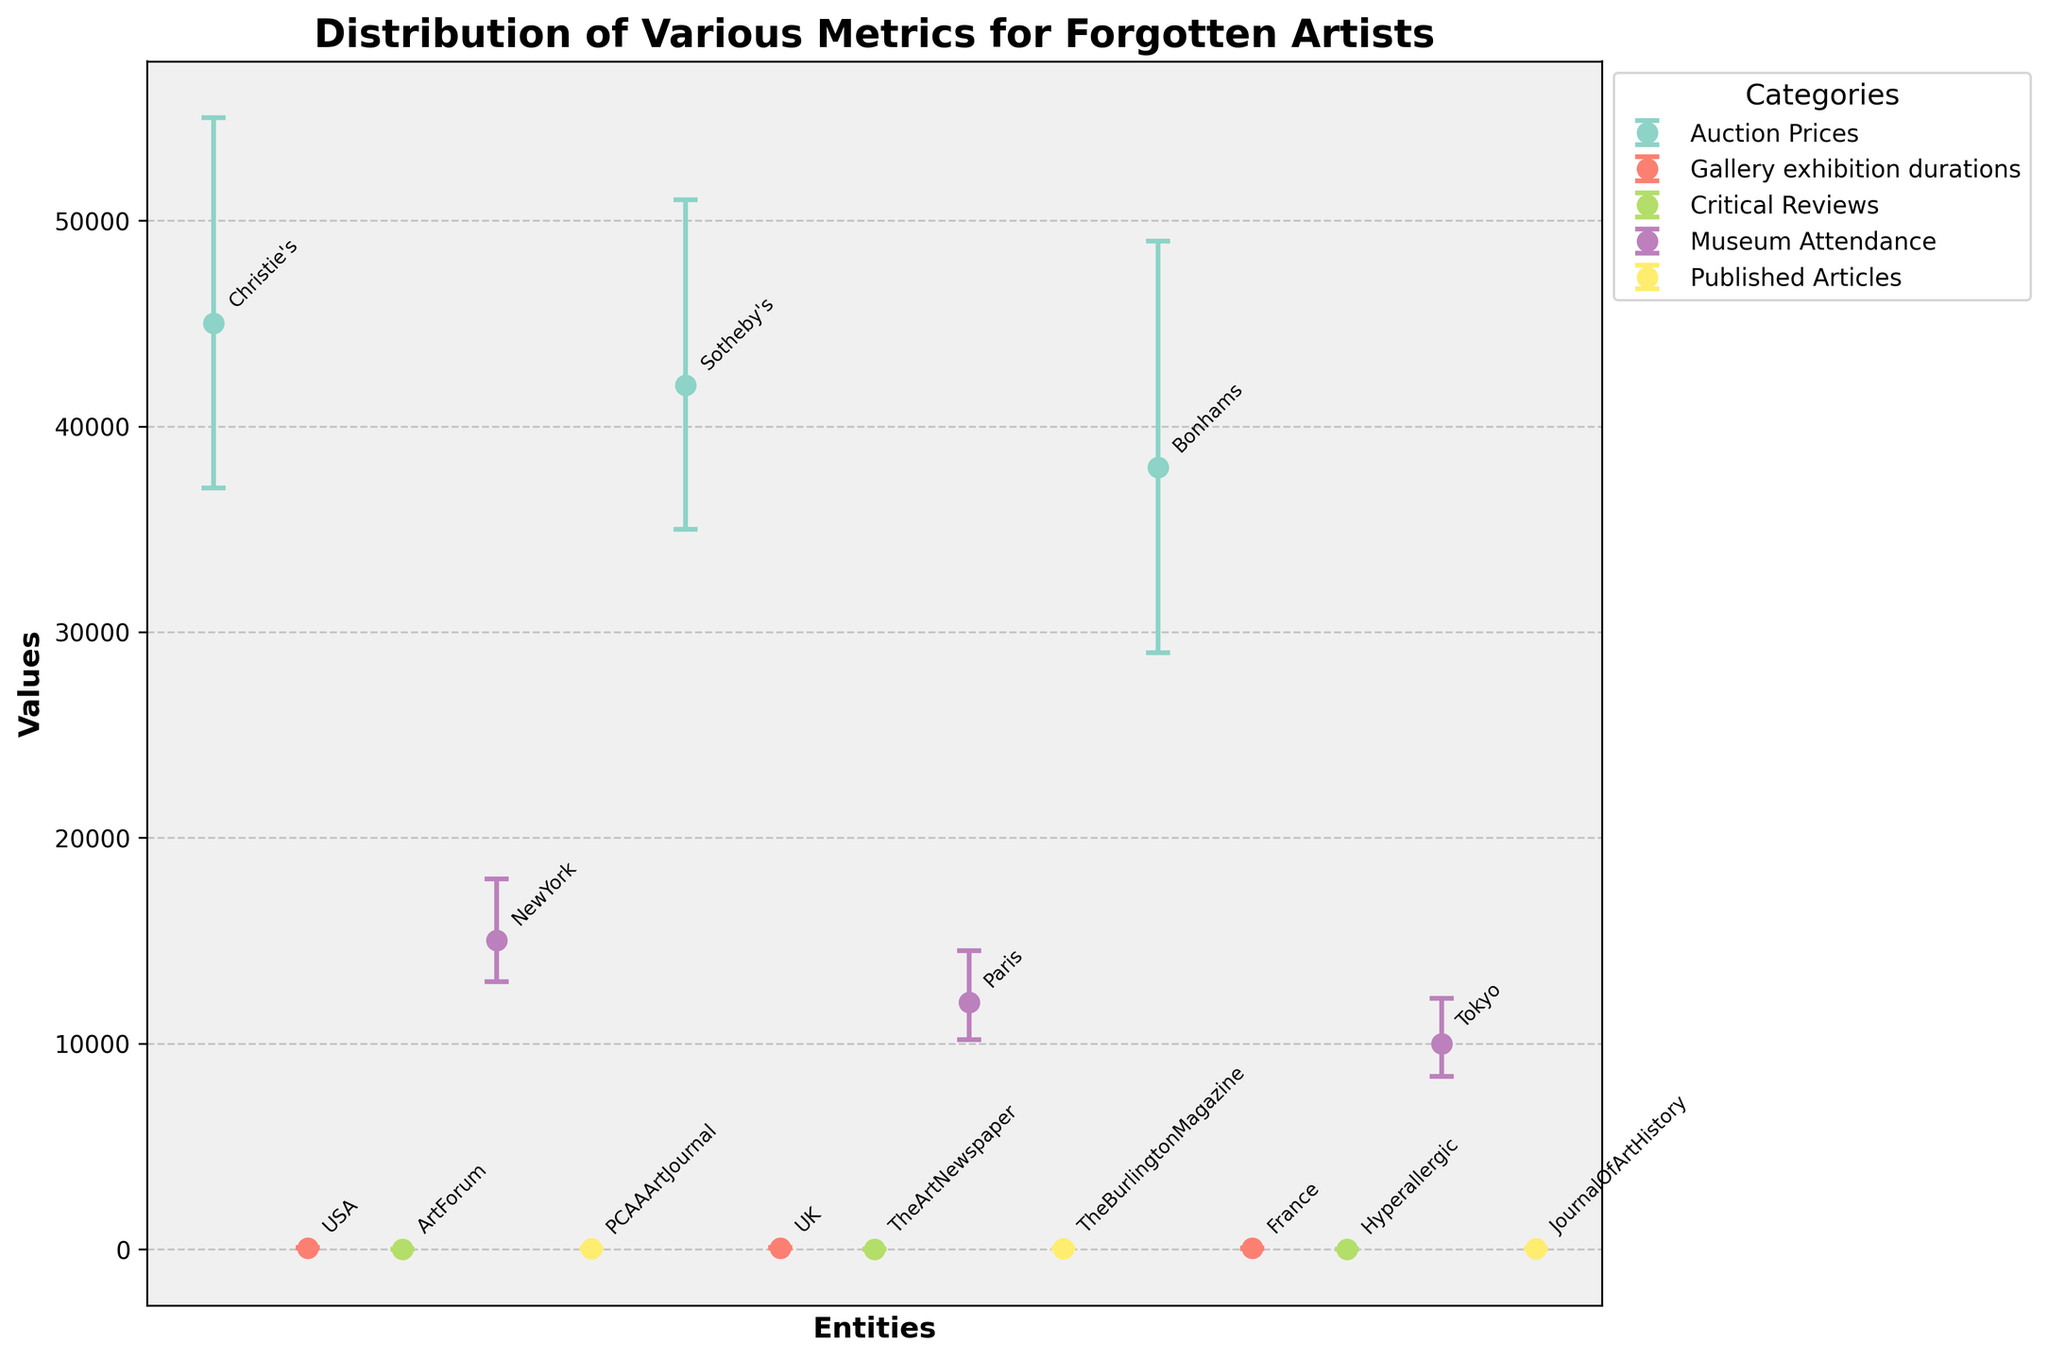What's the highest average auction price among the auction houses? Identify the category "Auction Prices" and compare the average prices. Christie's has an average price of 45,000, Sotheby's has 42,000, and Bonhams has 38,000. Christie's has the highest average auction price.
Answer: Christie's Which gallery exhibition duration has the smallest lower error bar? Look at the "Gallery exhibition durations" category. The lower error bars for USA, UK, and France are 10, 15, and 8, respectively. France has the smallest lower error bar.
Answer: France What’s the range of critical review scores for ArtForum? Identify the mean and error bars for ArtForum in the "Critical Reviews" category. The mean is 7.8, with an upper error of 0.5 and a lower error of 0.2. The range is from 7.6 to 8.3.
Answer: 7.6 to 8.3 Which city has the highest average museum attendance? Compare average attendance figures for New York, Paris, and Tokyo under the "Museum Attendance" category. New York has 15,000, Paris has 12,000, and Tokyo has 10,000. New York has the highest average attendance.
Answer: New York What’s the difference between the highest and lowest average values in the "Published Articles" category? The average values for PCAAArtJournal, The Burlington Magazine, and JournalOfArtHistory are 25, 22, and 18, respectively. The difference between the highest (25) and the lowest (18) is 25 - 18 = 7.
Answer: 7 Which publication has the greatest variability in the number of published articles? Look at the "Published Articles" category and compare the ranges: PCAAArtJournal (5-3=2), TheBurlingtonMagazine (6-4=2), JournalOfArtHistory (4-3=1). The Burlington Magazine and PCAAArtJournal share the greatest variability.
Answer: The Burlington Magazine and PCAAArtJournal What’s the average duration of gallery exhibitions across all countries? Add the average durations of the USA (60), UK (70), and France (50) and divide by the number of entities: (60 + 70 + 50) / 3. The calculation is 180 / 3 = 60.
Answer: 60 Which metric has the smallest upper error bar among all plotted categories? Compare the "Upper Error" values across all categories. The smallest value is in the "Critical Reviews" category: ArtForum has an upper error of 0.5.
Answer: ArtForum How does the average critical review score for TheArtNewspaper compare to Hyperallergic? Find the mean scores in the "Critical Reviews" category: TheArtNewspaper is 7.5 and Hyperallergic is 7.2. TheArtNewspaper's average score is higher.
Answer: TheArtNewspaper What's the combined average attendance for museum exhibits in New York and Tokyo? Add the average attendance for New York (15,000) and Tokyo (10,000): 15,000 + 10,000 = 25,000.
Answer: 25,000 